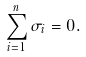Convert formula to latex. <formula><loc_0><loc_0><loc_500><loc_500>\sum _ { i = 1 } ^ { n } \sigma _ { i } = 0 . \label l { \sin g u l a r }</formula> 